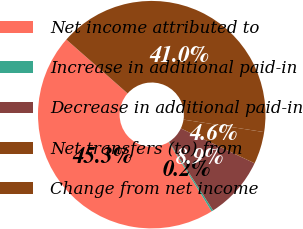<chart> <loc_0><loc_0><loc_500><loc_500><pie_chart><fcel>Net income attributed to<fcel>Increase in additional paid-in<fcel>Decrease in additional paid-in<fcel>Net transfers (to) from<fcel>Change from net income<nl><fcel>45.3%<fcel>0.25%<fcel>8.9%<fcel>4.58%<fcel>40.97%<nl></chart> 